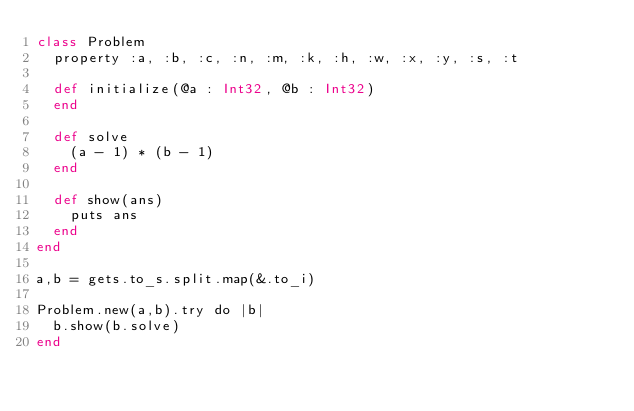Convert code to text. <code><loc_0><loc_0><loc_500><loc_500><_Crystal_>class Problem
  property :a, :b, :c, :n, :m, :k, :h, :w, :x, :y, :s, :t

  def initialize(@a : Int32, @b : Int32)
  end

  def solve
    (a - 1) * (b - 1)
  end

  def show(ans)
    puts ans
  end
end

a,b = gets.to_s.split.map(&.to_i)

Problem.new(a,b).try do |b|
  b.show(b.solve)
end
</code> 